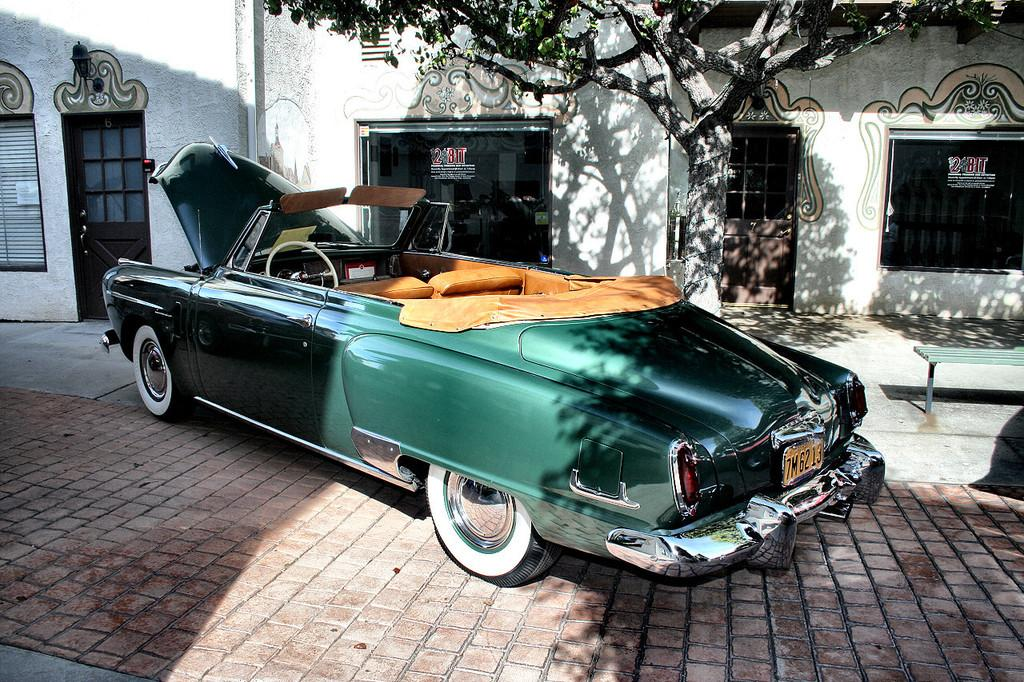What is placed on the sidewalk in the image? There is a car placed on a sidewalk in the image. What is in front of the car? There is a building in front of the car. Can you describe the left side of the image? There is a door on the left side of the image. What is on the right side of the image? There is a tree on the right side of the image. What type of apparel is the rat wearing in the image? There is no rat present in the image, and therefore no apparel can be associated with it. 